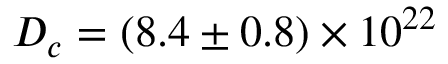<formula> <loc_0><loc_0><loc_500><loc_500>D _ { c } = ( 8 . 4 \pm 0 . 8 ) \times 1 0 ^ { 2 2 }</formula> 